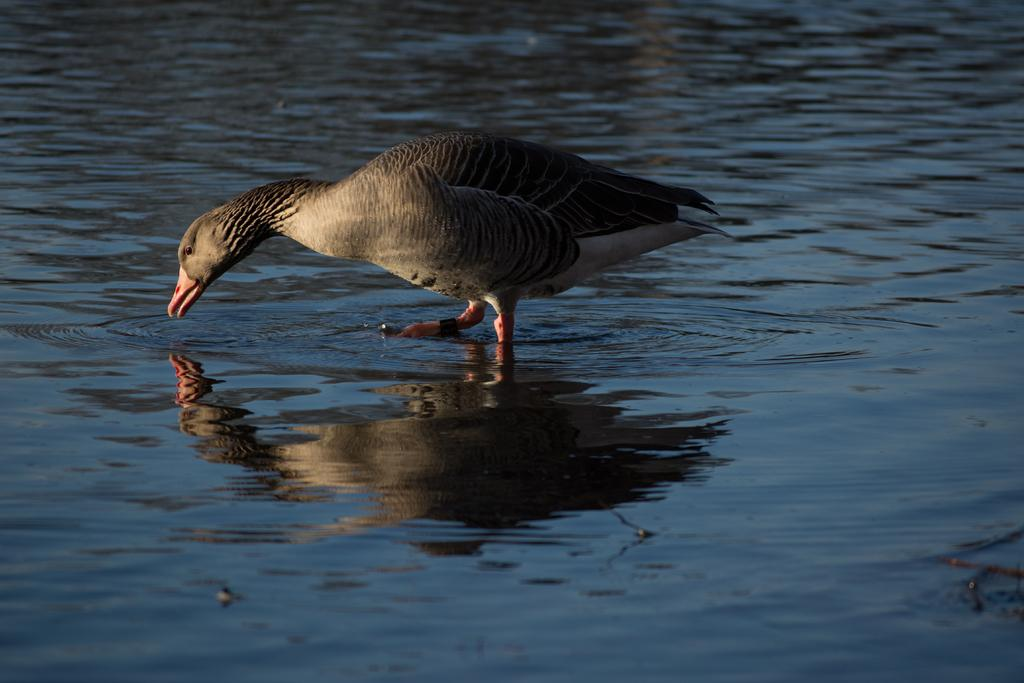What is the primary element visible in the image? There is water in the image. Is there any wildlife present in the water? Yes, there is a duck standing in the middle of the water. What type of vase can be seen holding the clam in the image? There is no vase or clam present in the image; it features water with a duck standing in it. What kind of beast is lurking beneath the surface of the water in the image? There is no beast present in the image; it only features a duck standing in the water. 